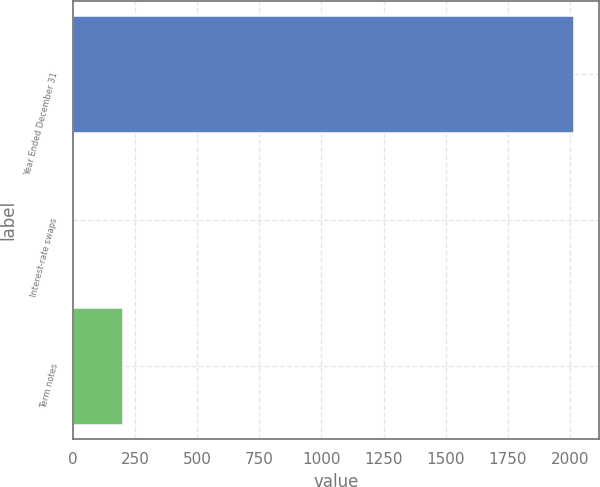Convert chart to OTSL. <chart><loc_0><loc_0><loc_500><loc_500><bar_chart><fcel>Year Ended December 31<fcel>Interest-rate swaps<fcel>Term notes<nl><fcel>2014<fcel>0.1<fcel>201.49<nl></chart> 